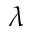Convert formula to latex. <formula><loc_0><loc_0><loc_500><loc_500>\lambda</formula> 